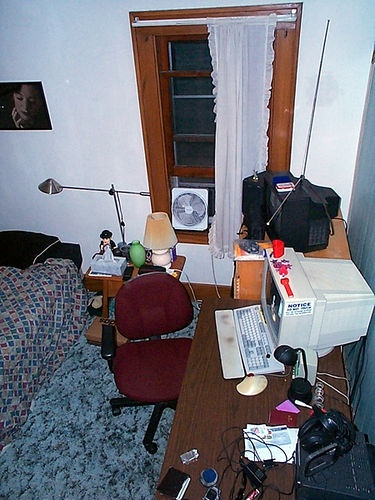Describe the objects in this image and their specific colors. I can see bed in gray, black, navy, and blue tones, chair in gray, black, maroon, and brown tones, tv in gray, lightgray, lightblue, and darkgray tones, tv in gray, black, and white tones, and keyboard in gray, lavender, darkgray, and lightblue tones in this image. 